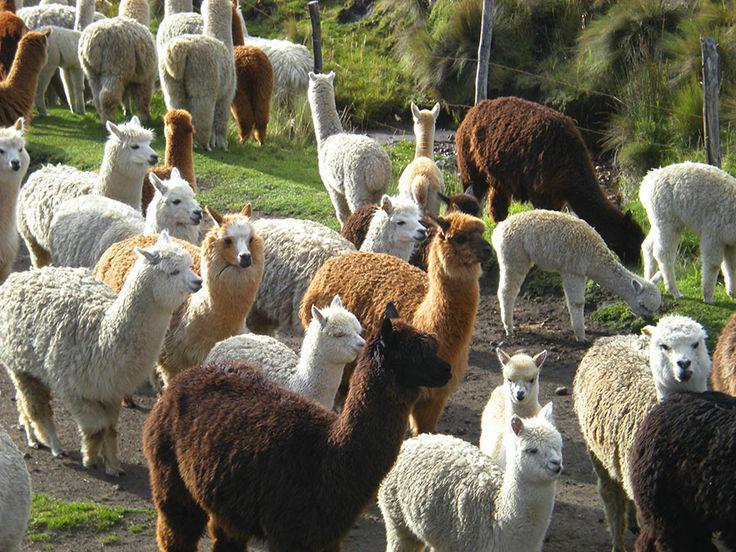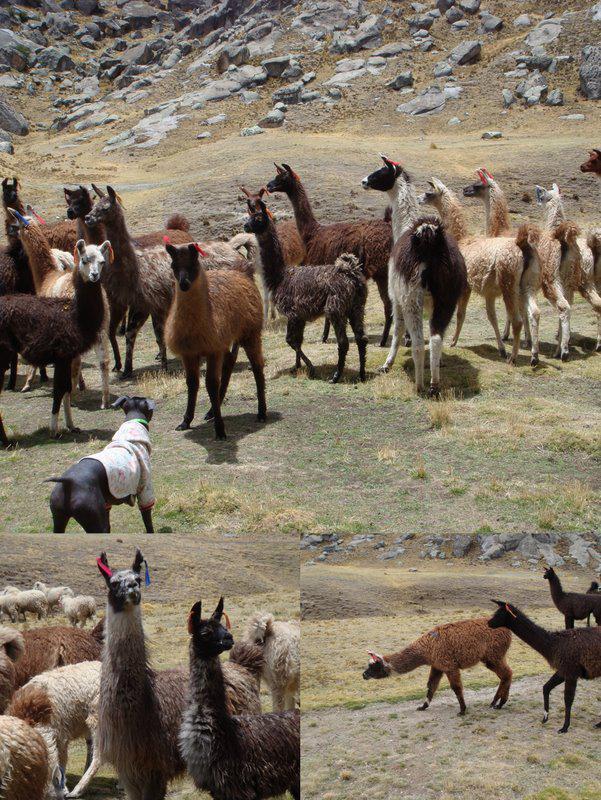The first image is the image on the left, the second image is the image on the right. For the images shown, is this caption "One image shows at least ten llamas standing in place with their heads upright and angled rightward." true? Answer yes or no. Yes. 